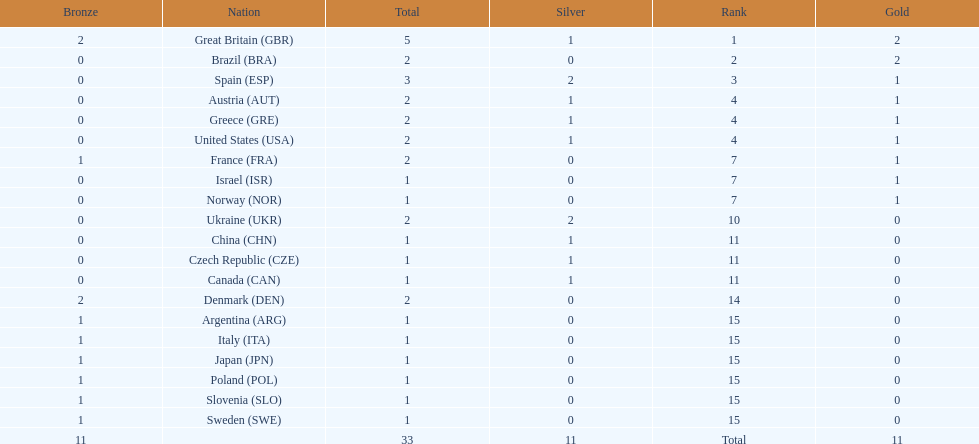How many countries won at least 1 gold and 1 silver medal? 5. 